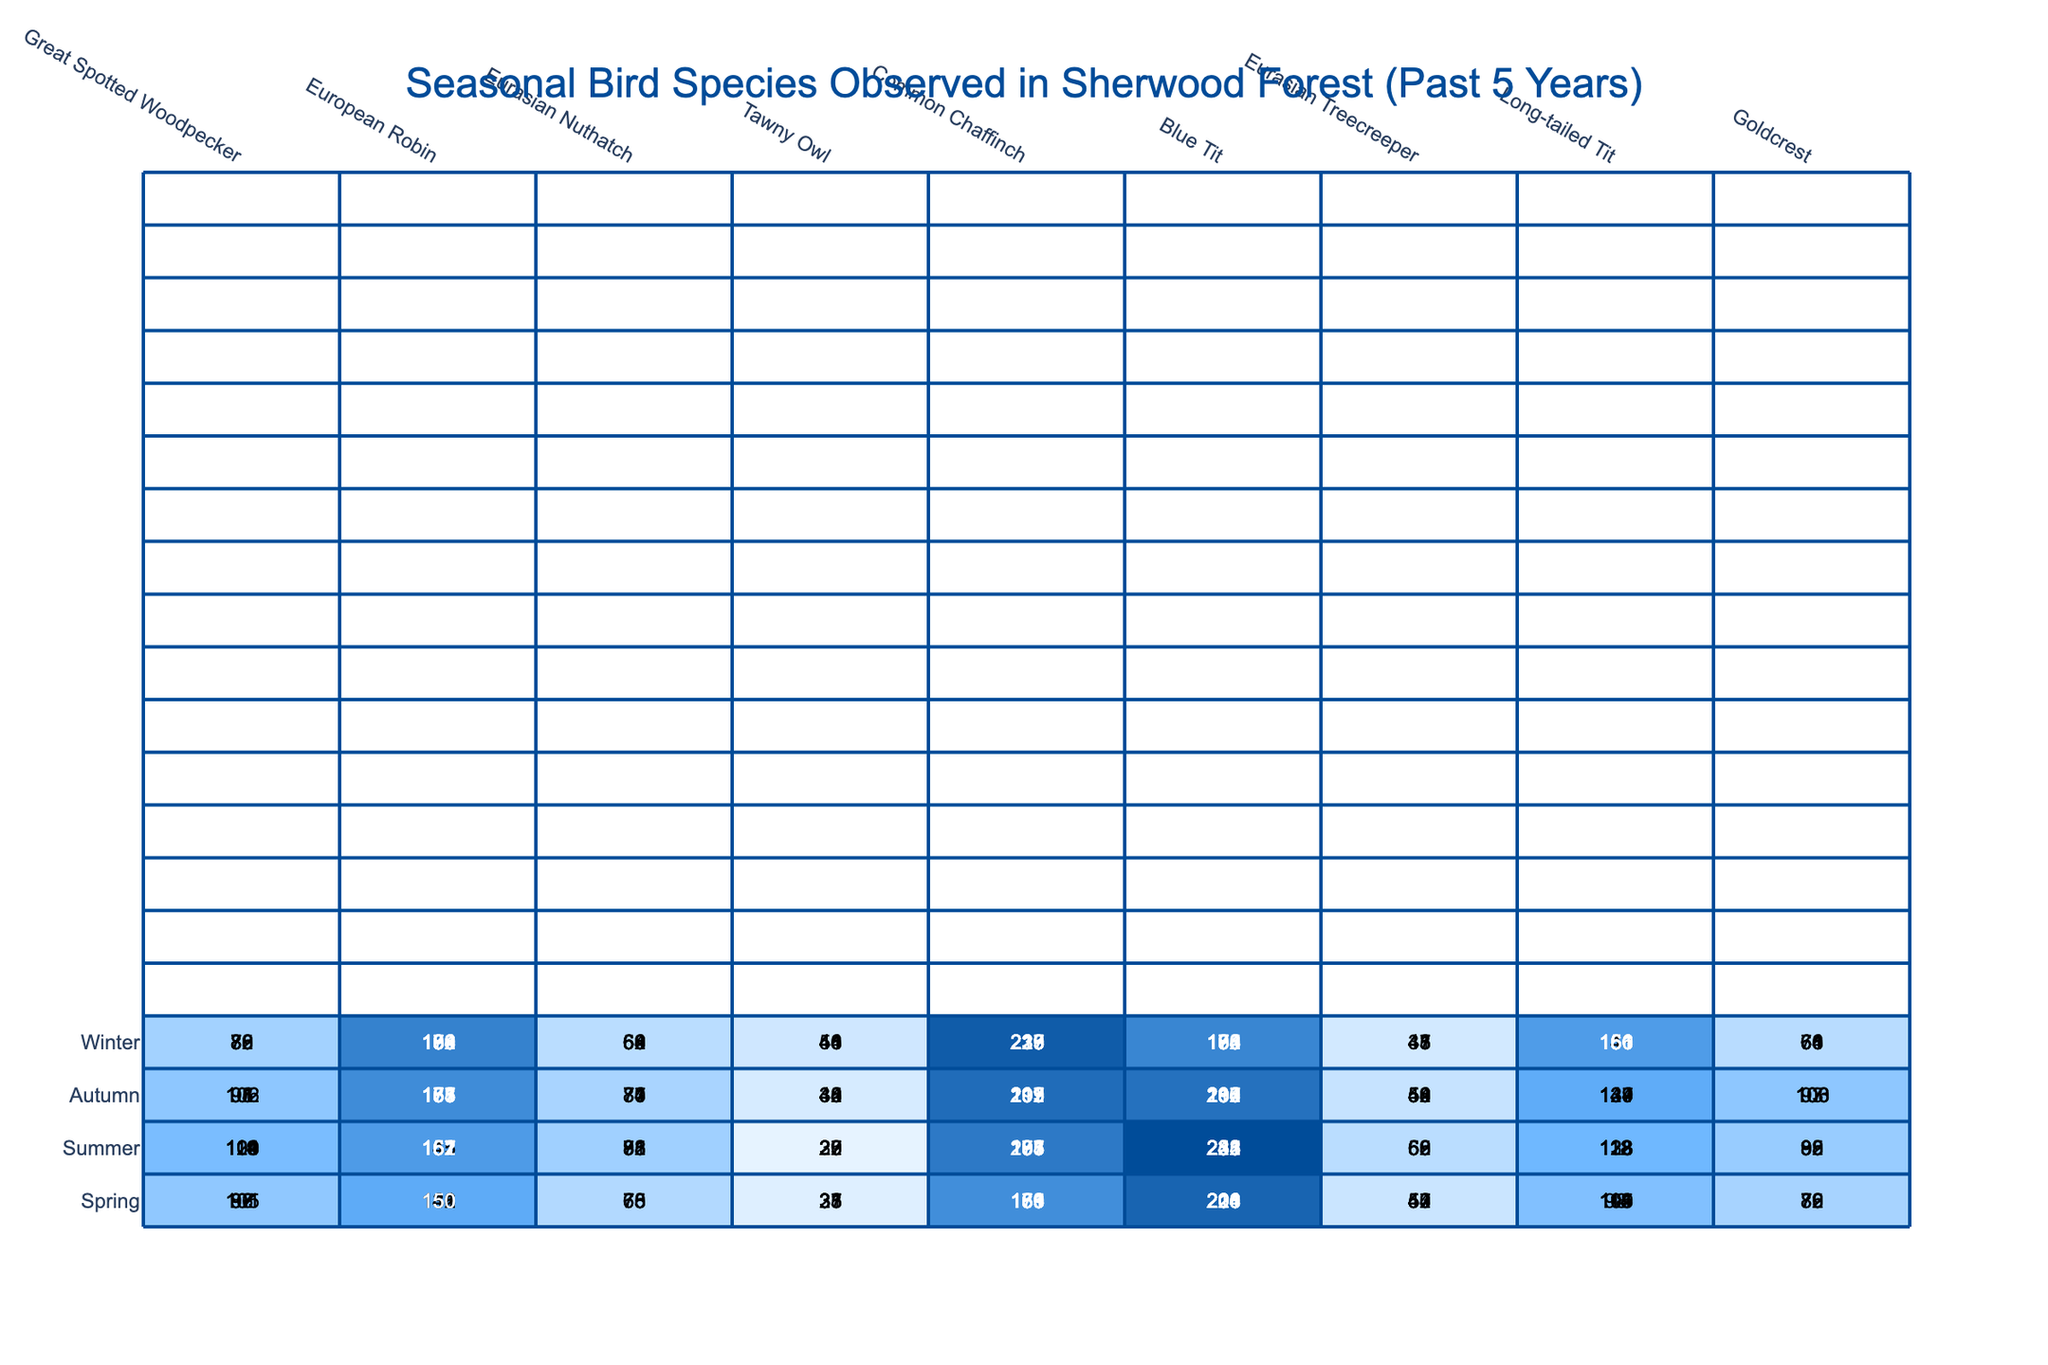What is the highest number of Great Spotted Woodpeckers observed in a single season? From the table, the number of Great Spotted Woodpeckers for each season is: Spring (87, 92, 96, 101, 105), Summer (103, 109, 114, 119, 124), Autumn (91, 95, 98, 102, 106), and Winter (76, 79, 82, 85, 88). The highest value is 124 during Summer.
Answer: 124 Which season had the least number of Eurasian Nuthatches observed? The Eurasian Nuthatch counts for each season are: Spring (65, 68, 70, 73, 75), Summer (78, 82, 85, 88, 91), Autumn (71, 74, 77, 80, 83), and Winter (59, 62, 64, 66, 68). The smallest value is 59 in Winter.
Answer: 59 What is the average number of European Robins observed in Autumn? The numbers for European Robins in Autumn were 158, 165, 171, 177, and 183. Summing these gives 158 + 165 + 171 + 177 + 183 = 854. There are 5 seasons, so the average is 854 / 5 = 170.8, which can be rounded to 171.
Answer: 171 Have the Common Chaffinches ever been observed with a count below 150? Looking at the counts for Common Chaffinch across all seasons: Spring (156, 163, 169, 175, 181), Summer (178, 185, 191, 197, 203), Autumn (192, 199, 205, 211, 217), and Winter (210, 217, 223, 229, 235), none of them fall below 150.
Answer: No Is the observation of the Blue Tit generally increasing over the years? Analyzing the counts for Blue Tit by season: Spring (201, 208, 214, 220, 226), Summer (223, 231, 238, 245, 252), Autumn (187, 194, 200, 206, 212), and Winter (165, 172, 178, 184, 190). Each season shows an increase over the years; thus, their population is on an upward trend.
Answer: Yes What is the difference in the number of Goldcrests observed between Spring and Autumn in the most recent data? The counts for Goldcrests in the most recent Spring and Autumn are 85 (Spring) and 106 (Autumn). The difference is 106 - 85 = 21.
Answer: 21 Which bird species had consistent observations of 100 or more across all seasons? Checking each bird species, only European Robin counts are always 100 or more: (132, 138, 141, 146, 150 in Spring; 145, 151, 157, 162, 167 in Summer; etc.). Others fluctuate.
Answer: European Robin What is the total number of Eurasian Treecreepers observed in Winter across five years? The counts for Eurasian Treecreeper in Winter are: 38, 41, 43, 45, 47. Summing these yields 38 + 41 + 43 + 45 + 47 = 214.
Answer: 214 Which species had the highest average observation across all seasons? The following are the averages: Great Spotted Woodpecker - 89.2, European Robin - 152.2, Eurasian Nuthatch - 71.8, Tawny Owl - 38.4, Common Chaffinch - 202.8, Blue Tit - 198.6, Eurasian Treecreeper - 48.6, Long-tailed Tit - 126.8, Goldcrest - 81.8. The highest average is for Common Chaffinch.
Answer: Common Chaffinch How many Tawny Owls were observed in the most productive season? The counts for Tawny Owl across the seasons are: 28, 22, 35, 41, 31, 25, 38, 44, 33, 29, 40, 42, 37, 30, 44, 50. The maximum is 50 in Winter of the most recent year.
Answer: 50 